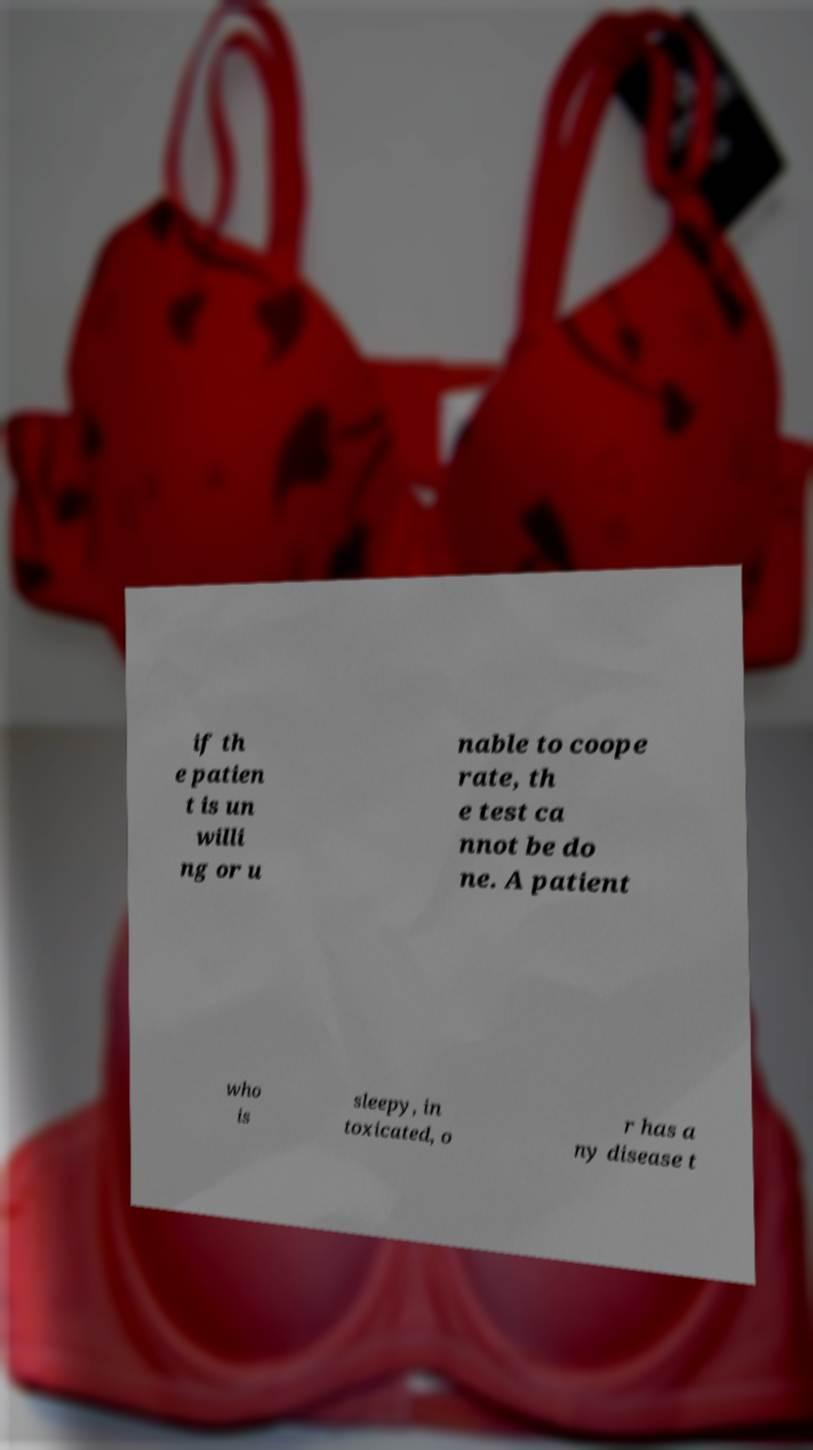I need the written content from this picture converted into text. Can you do that? if th e patien t is un willi ng or u nable to coope rate, th e test ca nnot be do ne. A patient who is sleepy, in toxicated, o r has a ny disease t 